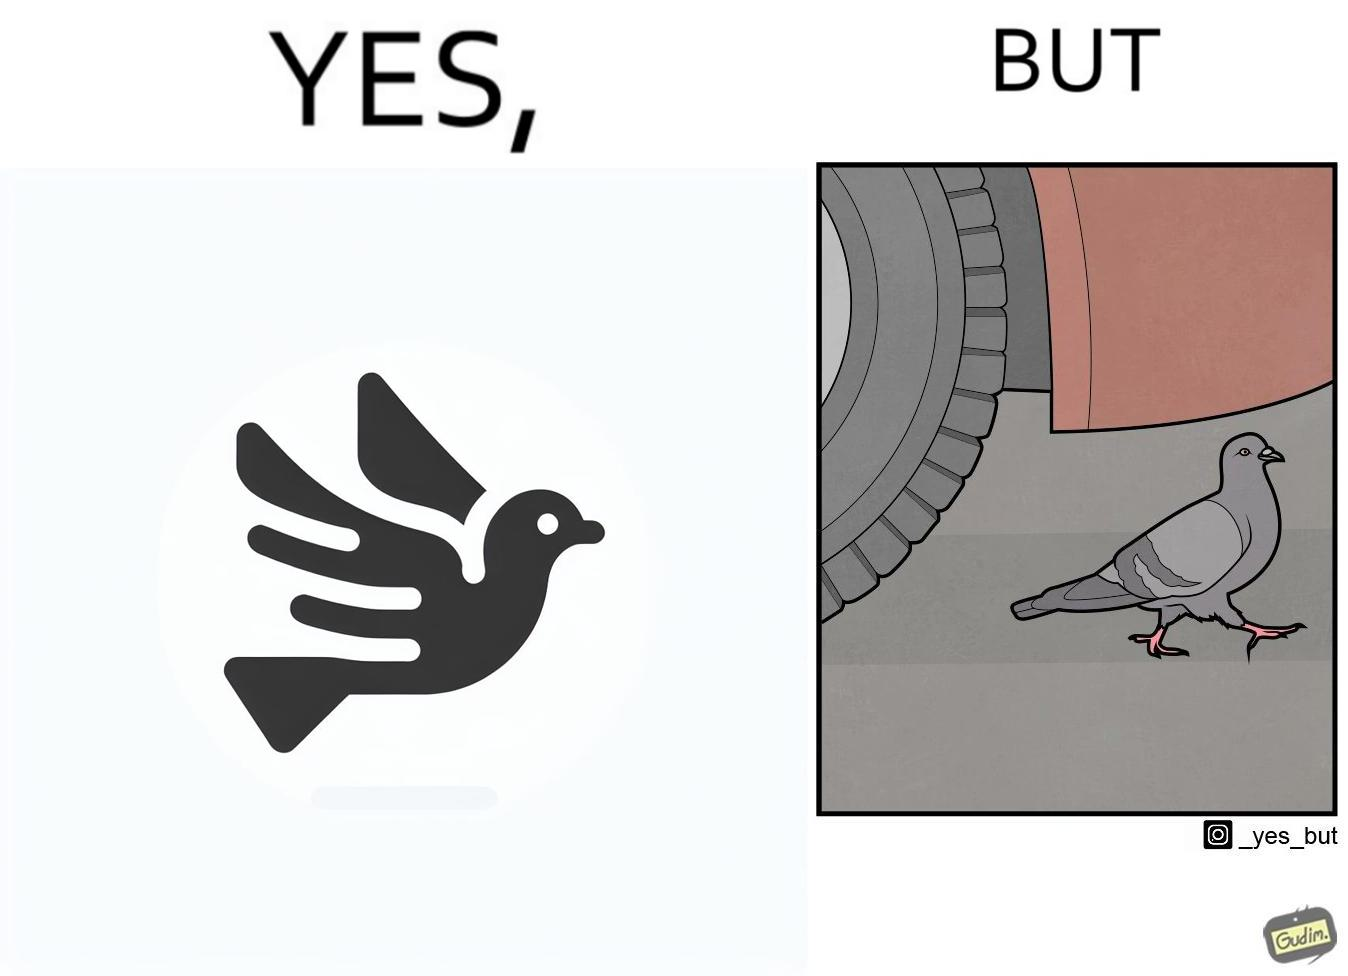What is the satirical meaning behind this image? The image is ironic, because even when the pigeon has wings to fly it is walking even when it seems threatening to its life 